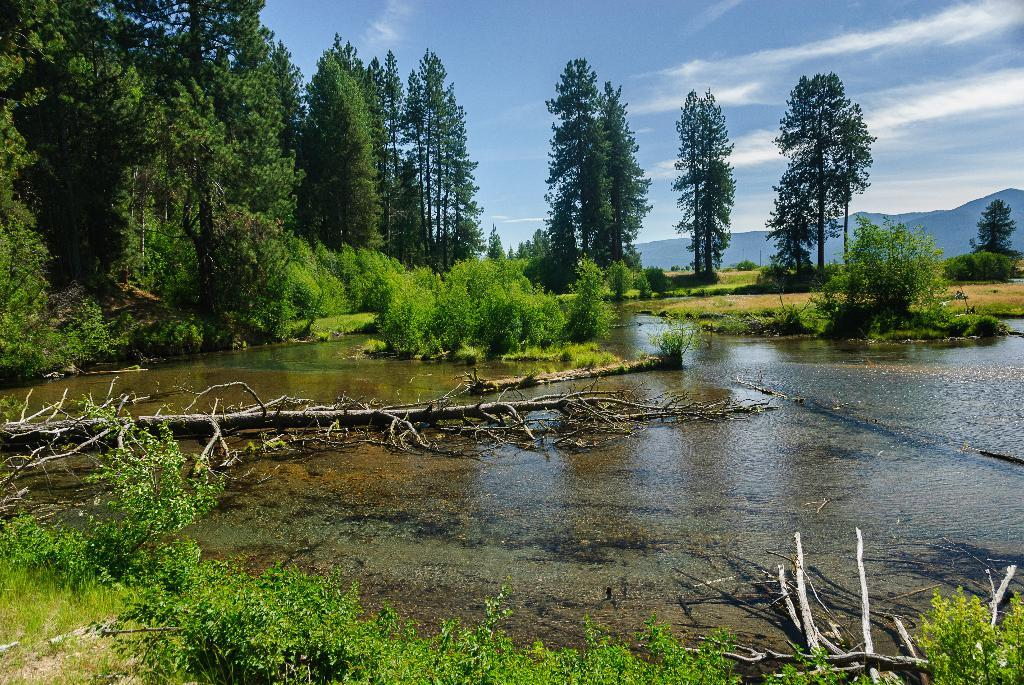What type of vegetation can be seen near the lake in the image? There are trees beside the lake in the image. What can be found at the bottom of the image? There are plants at the bottom of the image. What is visible at the top of the image? The sky is visible at the top of the image. Where is the badge located in the image? There is no badge present in the image. What type of food is being cooked in the oven in the image? There is no oven present in the image. 